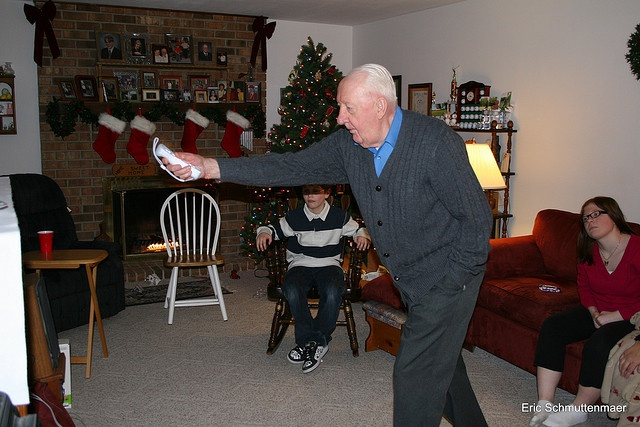Describe the objects in this image and their specific colors. I can see people in gray, black, and lightpink tones, people in gray, black, and maroon tones, couch in gray, black, and maroon tones, people in gray, black, and darkgray tones, and couch in gray, black, and maroon tones in this image. 